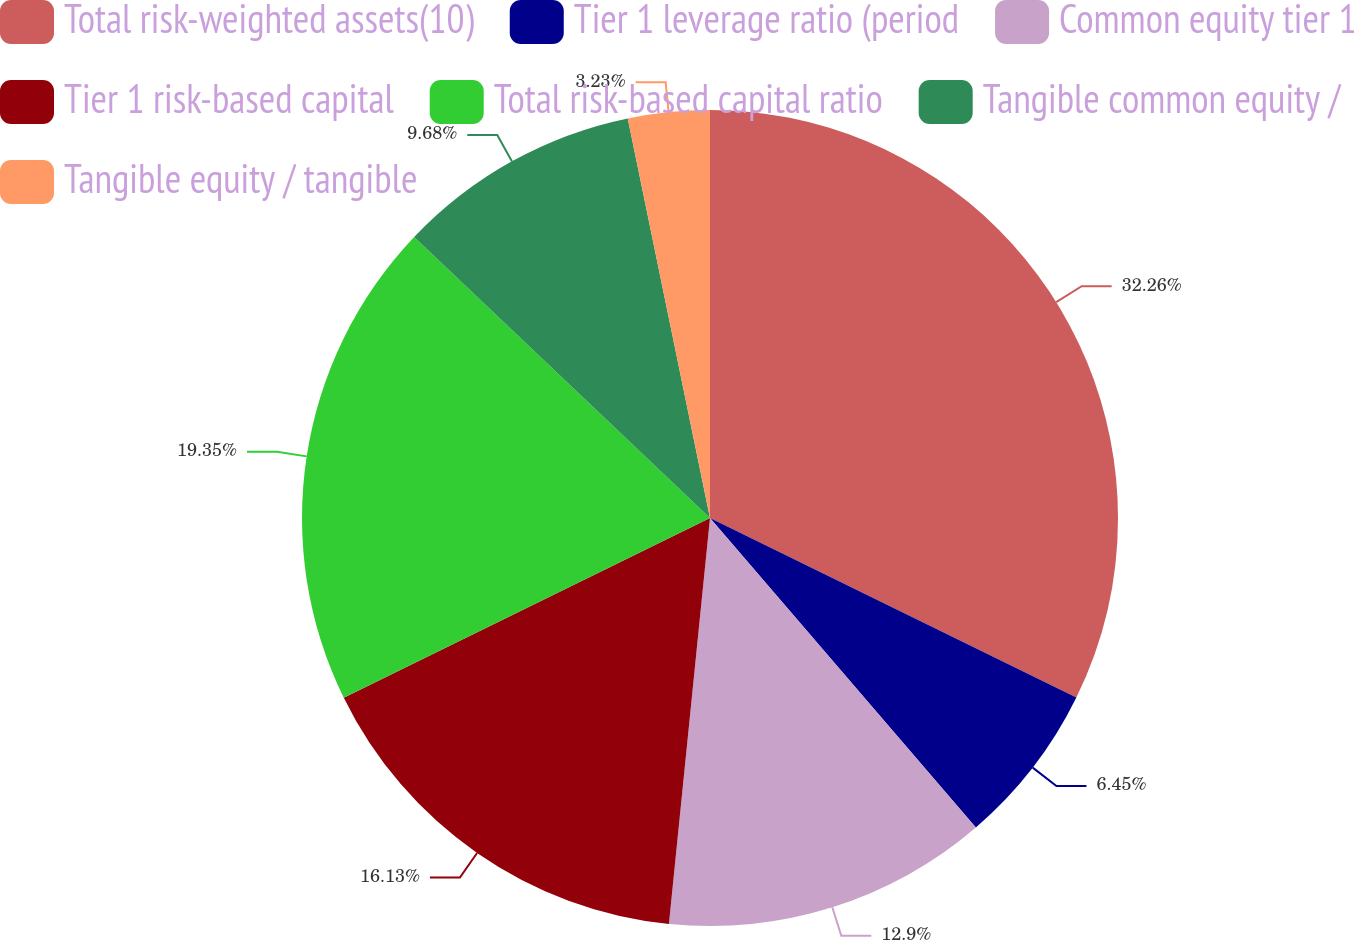Convert chart. <chart><loc_0><loc_0><loc_500><loc_500><pie_chart><fcel>Total risk-weighted assets(10)<fcel>Tier 1 leverage ratio (period<fcel>Common equity tier 1<fcel>Tier 1 risk-based capital<fcel>Total risk-based capital ratio<fcel>Tangible common equity /<fcel>Tangible equity / tangible<nl><fcel>32.25%<fcel>6.45%<fcel>12.9%<fcel>16.13%<fcel>19.35%<fcel>9.68%<fcel>3.23%<nl></chart> 